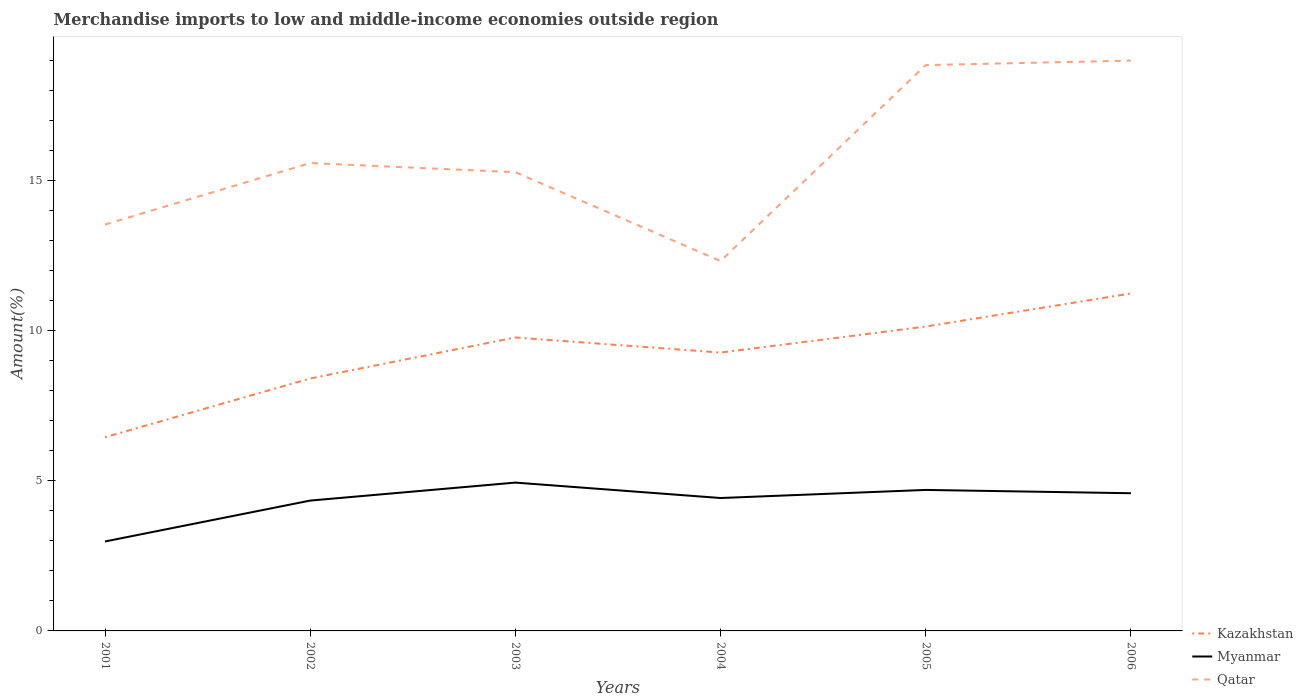Is the number of lines equal to the number of legend labels?
Your answer should be compact. Yes. Across all years, what is the maximum percentage of amount earned from merchandise imports in Qatar?
Ensure brevity in your answer.  12.33. In which year was the percentage of amount earned from merchandise imports in Myanmar maximum?
Give a very brief answer. 2001. What is the total percentage of amount earned from merchandise imports in Kazakhstan in the graph?
Provide a short and direct response. -4.79. What is the difference between the highest and the second highest percentage of amount earned from merchandise imports in Qatar?
Your answer should be very brief. 6.68. What is the difference between the highest and the lowest percentage of amount earned from merchandise imports in Qatar?
Offer a very short reply. 2. Is the percentage of amount earned from merchandise imports in Qatar strictly greater than the percentage of amount earned from merchandise imports in Kazakhstan over the years?
Your answer should be very brief. No. How many lines are there?
Ensure brevity in your answer.  3. Are the values on the major ticks of Y-axis written in scientific E-notation?
Make the answer very short. No. Does the graph contain grids?
Ensure brevity in your answer.  No. Where does the legend appear in the graph?
Keep it short and to the point. Bottom right. How many legend labels are there?
Provide a short and direct response. 3. How are the legend labels stacked?
Ensure brevity in your answer.  Vertical. What is the title of the graph?
Provide a short and direct response. Merchandise imports to low and middle-income economies outside region. What is the label or title of the X-axis?
Give a very brief answer. Years. What is the label or title of the Y-axis?
Your response must be concise. Amount(%). What is the Amount(%) of Kazakhstan in 2001?
Provide a succinct answer. 6.45. What is the Amount(%) in Myanmar in 2001?
Keep it short and to the point. 2.98. What is the Amount(%) in Qatar in 2001?
Keep it short and to the point. 13.54. What is the Amount(%) of Kazakhstan in 2002?
Offer a very short reply. 8.41. What is the Amount(%) of Myanmar in 2002?
Offer a terse response. 4.34. What is the Amount(%) of Qatar in 2002?
Your response must be concise. 15.59. What is the Amount(%) in Kazakhstan in 2003?
Provide a succinct answer. 9.78. What is the Amount(%) of Myanmar in 2003?
Make the answer very short. 4.94. What is the Amount(%) of Qatar in 2003?
Provide a short and direct response. 15.29. What is the Amount(%) in Kazakhstan in 2004?
Your response must be concise. 9.28. What is the Amount(%) in Myanmar in 2004?
Your answer should be compact. 4.43. What is the Amount(%) in Qatar in 2004?
Provide a short and direct response. 12.33. What is the Amount(%) in Kazakhstan in 2005?
Provide a short and direct response. 10.15. What is the Amount(%) in Myanmar in 2005?
Provide a short and direct response. 4.7. What is the Amount(%) of Qatar in 2005?
Keep it short and to the point. 18.86. What is the Amount(%) in Kazakhstan in 2006?
Provide a short and direct response. 11.25. What is the Amount(%) in Myanmar in 2006?
Your answer should be compact. 4.59. What is the Amount(%) of Qatar in 2006?
Give a very brief answer. 19.01. Across all years, what is the maximum Amount(%) of Kazakhstan?
Make the answer very short. 11.25. Across all years, what is the maximum Amount(%) of Myanmar?
Provide a succinct answer. 4.94. Across all years, what is the maximum Amount(%) in Qatar?
Make the answer very short. 19.01. Across all years, what is the minimum Amount(%) in Kazakhstan?
Offer a very short reply. 6.45. Across all years, what is the minimum Amount(%) in Myanmar?
Your answer should be very brief. 2.98. Across all years, what is the minimum Amount(%) of Qatar?
Ensure brevity in your answer.  12.33. What is the total Amount(%) of Kazakhstan in the graph?
Offer a terse response. 55.32. What is the total Amount(%) in Myanmar in the graph?
Give a very brief answer. 25.99. What is the total Amount(%) in Qatar in the graph?
Your response must be concise. 94.62. What is the difference between the Amount(%) in Kazakhstan in 2001 and that in 2002?
Offer a very short reply. -1.96. What is the difference between the Amount(%) in Myanmar in 2001 and that in 2002?
Offer a terse response. -1.36. What is the difference between the Amount(%) of Qatar in 2001 and that in 2002?
Offer a very short reply. -2.05. What is the difference between the Amount(%) of Kazakhstan in 2001 and that in 2003?
Your answer should be very brief. -3.33. What is the difference between the Amount(%) of Myanmar in 2001 and that in 2003?
Offer a terse response. -1.96. What is the difference between the Amount(%) of Qatar in 2001 and that in 2003?
Keep it short and to the point. -1.75. What is the difference between the Amount(%) of Kazakhstan in 2001 and that in 2004?
Provide a succinct answer. -2.82. What is the difference between the Amount(%) in Myanmar in 2001 and that in 2004?
Ensure brevity in your answer.  -1.45. What is the difference between the Amount(%) in Qatar in 2001 and that in 2004?
Provide a short and direct response. 1.22. What is the difference between the Amount(%) of Kazakhstan in 2001 and that in 2005?
Give a very brief answer. -3.69. What is the difference between the Amount(%) of Myanmar in 2001 and that in 2005?
Your response must be concise. -1.72. What is the difference between the Amount(%) in Qatar in 2001 and that in 2005?
Provide a succinct answer. -5.32. What is the difference between the Amount(%) in Kazakhstan in 2001 and that in 2006?
Keep it short and to the point. -4.79. What is the difference between the Amount(%) in Myanmar in 2001 and that in 2006?
Your answer should be very brief. -1.61. What is the difference between the Amount(%) of Qatar in 2001 and that in 2006?
Your answer should be very brief. -5.46. What is the difference between the Amount(%) of Kazakhstan in 2002 and that in 2003?
Keep it short and to the point. -1.37. What is the difference between the Amount(%) in Myanmar in 2002 and that in 2003?
Provide a short and direct response. -0.6. What is the difference between the Amount(%) in Qatar in 2002 and that in 2003?
Provide a short and direct response. 0.3. What is the difference between the Amount(%) in Kazakhstan in 2002 and that in 2004?
Your answer should be compact. -0.86. What is the difference between the Amount(%) in Myanmar in 2002 and that in 2004?
Offer a very short reply. -0.09. What is the difference between the Amount(%) of Qatar in 2002 and that in 2004?
Give a very brief answer. 3.27. What is the difference between the Amount(%) of Kazakhstan in 2002 and that in 2005?
Keep it short and to the point. -1.73. What is the difference between the Amount(%) of Myanmar in 2002 and that in 2005?
Offer a terse response. -0.36. What is the difference between the Amount(%) of Qatar in 2002 and that in 2005?
Keep it short and to the point. -3.27. What is the difference between the Amount(%) of Kazakhstan in 2002 and that in 2006?
Provide a short and direct response. -2.83. What is the difference between the Amount(%) of Myanmar in 2002 and that in 2006?
Make the answer very short. -0.24. What is the difference between the Amount(%) in Qatar in 2002 and that in 2006?
Keep it short and to the point. -3.41. What is the difference between the Amount(%) in Kazakhstan in 2003 and that in 2004?
Your answer should be very brief. 0.5. What is the difference between the Amount(%) in Myanmar in 2003 and that in 2004?
Your response must be concise. 0.51. What is the difference between the Amount(%) in Qatar in 2003 and that in 2004?
Your answer should be compact. 2.96. What is the difference between the Amount(%) in Kazakhstan in 2003 and that in 2005?
Keep it short and to the point. -0.36. What is the difference between the Amount(%) of Myanmar in 2003 and that in 2005?
Provide a succinct answer. 0.24. What is the difference between the Amount(%) of Qatar in 2003 and that in 2005?
Offer a very short reply. -3.57. What is the difference between the Amount(%) of Kazakhstan in 2003 and that in 2006?
Your answer should be compact. -1.47. What is the difference between the Amount(%) in Myanmar in 2003 and that in 2006?
Make the answer very short. 0.35. What is the difference between the Amount(%) in Qatar in 2003 and that in 2006?
Offer a terse response. -3.72. What is the difference between the Amount(%) in Kazakhstan in 2004 and that in 2005?
Your response must be concise. -0.87. What is the difference between the Amount(%) of Myanmar in 2004 and that in 2005?
Ensure brevity in your answer.  -0.27. What is the difference between the Amount(%) of Qatar in 2004 and that in 2005?
Give a very brief answer. -6.53. What is the difference between the Amount(%) of Kazakhstan in 2004 and that in 2006?
Ensure brevity in your answer.  -1.97. What is the difference between the Amount(%) of Myanmar in 2004 and that in 2006?
Provide a short and direct response. -0.16. What is the difference between the Amount(%) of Qatar in 2004 and that in 2006?
Your answer should be compact. -6.68. What is the difference between the Amount(%) in Kazakhstan in 2005 and that in 2006?
Keep it short and to the point. -1.1. What is the difference between the Amount(%) of Myanmar in 2005 and that in 2006?
Provide a short and direct response. 0.11. What is the difference between the Amount(%) in Qatar in 2005 and that in 2006?
Offer a terse response. -0.15. What is the difference between the Amount(%) in Kazakhstan in 2001 and the Amount(%) in Myanmar in 2002?
Ensure brevity in your answer.  2.11. What is the difference between the Amount(%) of Kazakhstan in 2001 and the Amount(%) of Qatar in 2002?
Ensure brevity in your answer.  -9.14. What is the difference between the Amount(%) in Myanmar in 2001 and the Amount(%) in Qatar in 2002?
Offer a very short reply. -12.61. What is the difference between the Amount(%) in Kazakhstan in 2001 and the Amount(%) in Myanmar in 2003?
Your answer should be very brief. 1.51. What is the difference between the Amount(%) in Kazakhstan in 2001 and the Amount(%) in Qatar in 2003?
Make the answer very short. -8.83. What is the difference between the Amount(%) in Myanmar in 2001 and the Amount(%) in Qatar in 2003?
Keep it short and to the point. -12.31. What is the difference between the Amount(%) in Kazakhstan in 2001 and the Amount(%) in Myanmar in 2004?
Offer a terse response. 2.03. What is the difference between the Amount(%) of Kazakhstan in 2001 and the Amount(%) of Qatar in 2004?
Make the answer very short. -5.87. What is the difference between the Amount(%) of Myanmar in 2001 and the Amount(%) of Qatar in 2004?
Your answer should be compact. -9.35. What is the difference between the Amount(%) of Kazakhstan in 2001 and the Amount(%) of Myanmar in 2005?
Your answer should be compact. 1.76. What is the difference between the Amount(%) of Kazakhstan in 2001 and the Amount(%) of Qatar in 2005?
Offer a very short reply. -12.4. What is the difference between the Amount(%) in Myanmar in 2001 and the Amount(%) in Qatar in 2005?
Your answer should be compact. -15.88. What is the difference between the Amount(%) of Kazakhstan in 2001 and the Amount(%) of Myanmar in 2006?
Your answer should be very brief. 1.87. What is the difference between the Amount(%) of Kazakhstan in 2001 and the Amount(%) of Qatar in 2006?
Offer a very short reply. -12.55. What is the difference between the Amount(%) of Myanmar in 2001 and the Amount(%) of Qatar in 2006?
Your answer should be very brief. -16.03. What is the difference between the Amount(%) of Kazakhstan in 2002 and the Amount(%) of Myanmar in 2003?
Keep it short and to the point. 3.47. What is the difference between the Amount(%) in Kazakhstan in 2002 and the Amount(%) in Qatar in 2003?
Provide a succinct answer. -6.88. What is the difference between the Amount(%) in Myanmar in 2002 and the Amount(%) in Qatar in 2003?
Keep it short and to the point. -10.95. What is the difference between the Amount(%) of Kazakhstan in 2002 and the Amount(%) of Myanmar in 2004?
Your response must be concise. 3.98. What is the difference between the Amount(%) in Kazakhstan in 2002 and the Amount(%) in Qatar in 2004?
Your answer should be very brief. -3.92. What is the difference between the Amount(%) of Myanmar in 2002 and the Amount(%) of Qatar in 2004?
Offer a terse response. -7.98. What is the difference between the Amount(%) in Kazakhstan in 2002 and the Amount(%) in Myanmar in 2005?
Make the answer very short. 3.71. What is the difference between the Amount(%) of Kazakhstan in 2002 and the Amount(%) of Qatar in 2005?
Ensure brevity in your answer.  -10.45. What is the difference between the Amount(%) of Myanmar in 2002 and the Amount(%) of Qatar in 2005?
Provide a short and direct response. -14.52. What is the difference between the Amount(%) of Kazakhstan in 2002 and the Amount(%) of Myanmar in 2006?
Your answer should be compact. 3.82. What is the difference between the Amount(%) of Kazakhstan in 2002 and the Amount(%) of Qatar in 2006?
Make the answer very short. -10.6. What is the difference between the Amount(%) in Myanmar in 2002 and the Amount(%) in Qatar in 2006?
Offer a very short reply. -14.66. What is the difference between the Amount(%) of Kazakhstan in 2003 and the Amount(%) of Myanmar in 2004?
Your answer should be very brief. 5.35. What is the difference between the Amount(%) of Kazakhstan in 2003 and the Amount(%) of Qatar in 2004?
Offer a very short reply. -2.55. What is the difference between the Amount(%) in Myanmar in 2003 and the Amount(%) in Qatar in 2004?
Your answer should be compact. -7.38. What is the difference between the Amount(%) of Kazakhstan in 2003 and the Amount(%) of Myanmar in 2005?
Offer a terse response. 5.08. What is the difference between the Amount(%) of Kazakhstan in 2003 and the Amount(%) of Qatar in 2005?
Offer a terse response. -9.08. What is the difference between the Amount(%) in Myanmar in 2003 and the Amount(%) in Qatar in 2005?
Provide a succinct answer. -13.92. What is the difference between the Amount(%) in Kazakhstan in 2003 and the Amount(%) in Myanmar in 2006?
Your response must be concise. 5.19. What is the difference between the Amount(%) in Kazakhstan in 2003 and the Amount(%) in Qatar in 2006?
Your answer should be compact. -9.23. What is the difference between the Amount(%) in Myanmar in 2003 and the Amount(%) in Qatar in 2006?
Your answer should be very brief. -14.06. What is the difference between the Amount(%) of Kazakhstan in 2004 and the Amount(%) of Myanmar in 2005?
Ensure brevity in your answer.  4.58. What is the difference between the Amount(%) in Kazakhstan in 2004 and the Amount(%) in Qatar in 2005?
Give a very brief answer. -9.58. What is the difference between the Amount(%) of Myanmar in 2004 and the Amount(%) of Qatar in 2005?
Ensure brevity in your answer.  -14.43. What is the difference between the Amount(%) of Kazakhstan in 2004 and the Amount(%) of Myanmar in 2006?
Your answer should be very brief. 4.69. What is the difference between the Amount(%) of Kazakhstan in 2004 and the Amount(%) of Qatar in 2006?
Offer a very short reply. -9.73. What is the difference between the Amount(%) of Myanmar in 2004 and the Amount(%) of Qatar in 2006?
Your answer should be compact. -14.58. What is the difference between the Amount(%) in Kazakhstan in 2005 and the Amount(%) in Myanmar in 2006?
Your response must be concise. 5.56. What is the difference between the Amount(%) in Kazakhstan in 2005 and the Amount(%) in Qatar in 2006?
Ensure brevity in your answer.  -8.86. What is the difference between the Amount(%) in Myanmar in 2005 and the Amount(%) in Qatar in 2006?
Provide a succinct answer. -14.31. What is the average Amount(%) of Kazakhstan per year?
Provide a succinct answer. 9.22. What is the average Amount(%) in Myanmar per year?
Make the answer very short. 4.33. What is the average Amount(%) in Qatar per year?
Your response must be concise. 15.77. In the year 2001, what is the difference between the Amount(%) in Kazakhstan and Amount(%) in Myanmar?
Provide a short and direct response. 3.47. In the year 2001, what is the difference between the Amount(%) in Kazakhstan and Amount(%) in Qatar?
Offer a terse response. -7.09. In the year 2001, what is the difference between the Amount(%) in Myanmar and Amount(%) in Qatar?
Offer a terse response. -10.56. In the year 2002, what is the difference between the Amount(%) in Kazakhstan and Amount(%) in Myanmar?
Make the answer very short. 4.07. In the year 2002, what is the difference between the Amount(%) of Kazakhstan and Amount(%) of Qatar?
Ensure brevity in your answer.  -7.18. In the year 2002, what is the difference between the Amount(%) of Myanmar and Amount(%) of Qatar?
Provide a short and direct response. -11.25. In the year 2003, what is the difference between the Amount(%) in Kazakhstan and Amount(%) in Myanmar?
Your answer should be very brief. 4.84. In the year 2003, what is the difference between the Amount(%) of Kazakhstan and Amount(%) of Qatar?
Keep it short and to the point. -5.51. In the year 2003, what is the difference between the Amount(%) in Myanmar and Amount(%) in Qatar?
Offer a very short reply. -10.35. In the year 2004, what is the difference between the Amount(%) in Kazakhstan and Amount(%) in Myanmar?
Offer a very short reply. 4.85. In the year 2004, what is the difference between the Amount(%) of Kazakhstan and Amount(%) of Qatar?
Keep it short and to the point. -3.05. In the year 2004, what is the difference between the Amount(%) of Myanmar and Amount(%) of Qatar?
Ensure brevity in your answer.  -7.9. In the year 2005, what is the difference between the Amount(%) of Kazakhstan and Amount(%) of Myanmar?
Provide a succinct answer. 5.45. In the year 2005, what is the difference between the Amount(%) in Kazakhstan and Amount(%) in Qatar?
Offer a very short reply. -8.71. In the year 2005, what is the difference between the Amount(%) in Myanmar and Amount(%) in Qatar?
Give a very brief answer. -14.16. In the year 2006, what is the difference between the Amount(%) in Kazakhstan and Amount(%) in Myanmar?
Ensure brevity in your answer.  6.66. In the year 2006, what is the difference between the Amount(%) in Kazakhstan and Amount(%) in Qatar?
Your response must be concise. -7.76. In the year 2006, what is the difference between the Amount(%) in Myanmar and Amount(%) in Qatar?
Provide a short and direct response. -14.42. What is the ratio of the Amount(%) in Kazakhstan in 2001 to that in 2002?
Your response must be concise. 0.77. What is the ratio of the Amount(%) of Myanmar in 2001 to that in 2002?
Give a very brief answer. 0.69. What is the ratio of the Amount(%) in Qatar in 2001 to that in 2002?
Make the answer very short. 0.87. What is the ratio of the Amount(%) of Kazakhstan in 2001 to that in 2003?
Your answer should be very brief. 0.66. What is the ratio of the Amount(%) of Myanmar in 2001 to that in 2003?
Your answer should be compact. 0.6. What is the ratio of the Amount(%) of Qatar in 2001 to that in 2003?
Your response must be concise. 0.89. What is the ratio of the Amount(%) of Kazakhstan in 2001 to that in 2004?
Your answer should be very brief. 0.7. What is the ratio of the Amount(%) of Myanmar in 2001 to that in 2004?
Provide a succinct answer. 0.67. What is the ratio of the Amount(%) in Qatar in 2001 to that in 2004?
Your answer should be very brief. 1.1. What is the ratio of the Amount(%) in Kazakhstan in 2001 to that in 2005?
Give a very brief answer. 0.64. What is the ratio of the Amount(%) of Myanmar in 2001 to that in 2005?
Your response must be concise. 0.63. What is the ratio of the Amount(%) in Qatar in 2001 to that in 2005?
Keep it short and to the point. 0.72. What is the ratio of the Amount(%) in Kazakhstan in 2001 to that in 2006?
Your response must be concise. 0.57. What is the ratio of the Amount(%) of Myanmar in 2001 to that in 2006?
Offer a very short reply. 0.65. What is the ratio of the Amount(%) of Qatar in 2001 to that in 2006?
Give a very brief answer. 0.71. What is the ratio of the Amount(%) in Kazakhstan in 2002 to that in 2003?
Offer a terse response. 0.86. What is the ratio of the Amount(%) of Myanmar in 2002 to that in 2003?
Offer a terse response. 0.88. What is the ratio of the Amount(%) in Qatar in 2002 to that in 2003?
Provide a short and direct response. 1.02. What is the ratio of the Amount(%) of Kazakhstan in 2002 to that in 2004?
Your response must be concise. 0.91. What is the ratio of the Amount(%) of Myanmar in 2002 to that in 2004?
Your answer should be compact. 0.98. What is the ratio of the Amount(%) in Qatar in 2002 to that in 2004?
Ensure brevity in your answer.  1.26. What is the ratio of the Amount(%) of Kazakhstan in 2002 to that in 2005?
Provide a short and direct response. 0.83. What is the ratio of the Amount(%) of Myanmar in 2002 to that in 2005?
Your response must be concise. 0.92. What is the ratio of the Amount(%) in Qatar in 2002 to that in 2005?
Your answer should be very brief. 0.83. What is the ratio of the Amount(%) of Kazakhstan in 2002 to that in 2006?
Provide a succinct answer. 0.75. What is the ratio of the Amount(%) in Myanmar in 2002 to that in 2006?
Offer a very short reply. 0.95. What is the ratio of the Amount(%) in Qatar in 2002 to that in 2006?
Make the answer very short. 0.82. What is the ratio of the Amount(%) in Kazakhstan in 2003 to that in 2004?
Make the answer very short. 1.05. What is the ratio of the Amount(%) in Myanmar in 2003 to that in 2004?
Provide a short and direct response. 1.12. What is the ratio of the Amount(%) in Qatar in 2003 to that in 2004?
Your answer should be compact. 1.24. What is the ratio of the Amount(%) in Kazakhstan in 2003 to that in 2005?
Offer a very short reply. 0.96. What is the ratio of the Amount(%) of Myanmar in 2003 to that in 2005?
Keep it short and to the point. 1.05. What is the ratio of the Amount(%) of Qatar in 2003 to that in 2005?
Ensure brevity in your answer.  0.81. What is the ratio of the Amount(%) of Kazakhstan in 2003 to that in 2006?
Offer a very short reply. 0.87. What is the ratio of the Amount(%) in Myanmar in 2003 to that in 2006?
Your answer should be very brief. 1.08. What is the ratio of the Amount(%) in Qatar in 2003 to that in 2006?
Provide a succinct answer. 0.8. What is the ratio of the Amount(%) in Kazakhstan in 2004 to that in 2005?
Your answer should be very brief. 0.91. What is the ratio of the Amount(%) in Myanmar in 2004 to that in 2005?
Give a very brief answer. 0.94. What is the ratio of the Amount(%) of Qatar in 2004 to that in 2005?
Offer a terse response. 0.65. What is the ratio of the Amount(%) in Kazakhstan in 2004 to that in 2006?
Keep it short and to the point. 0.82. What is the ratio of the Amount(%) in Myanmar in 2004 to that in 2006?
Your answer should be compact. 0.97. What is the ratio of the Amount(%) of Qatar in 2004 to that in 2006?
Offer a very short reply. 0.65. What is the ratio of the Amount(%) of Kazakhstan in 2005 to that in 2006?
Offer a terse response. 0.9. What is the ratio of the Amount(%) of Myanmar in 2005 to that in 2006?
Give a very brief answer. 1.02. What is the ratio of the Amount(%) of Qatar in 2005 to that in 2006?
Your answer should be very brief. 0.99. What is the difference between the highest and the second highest Amount(%) of Kazakhstan?
Your answer should be very brief. 1.1. What is the difference between the highest and the second highest Amount(%) in Myanmar?
Keep it short and to the point. 0.24. What is the difference between the highest and the second highest Amount(%) in Qatar?
Ensure brevity in your answer.  0.15. What is the difference between the highest and the lowest Amount(%) in Kazakhstan?
Your answer should be very brief. 4.79. What is the difference between the highest and the lowest Amount(%) in Myanmar?
Make the answer very short. 1.96. What is the difference between the highest and the lowest Amount(%) of Qatar?
Give a very brief answer. 6.68. 